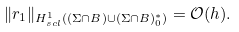<formula> <loc_0><loc_0><loc_500><loc_500>\| r _ { 1 } \| _ { H ^ { 1 } _ { s c l } ( ( \Sigma \cap B ) \cup ( \Sigma \cap B ) ^ { \ast } _ { 0 } ) } = \mathcal { O } ( h ) .</formula> 